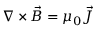<formula> <loc_0><loc_0><loc_500><loc_500>\nabla \times \vec { B } = \mu _ { 0 } \vec { J }</formula> 